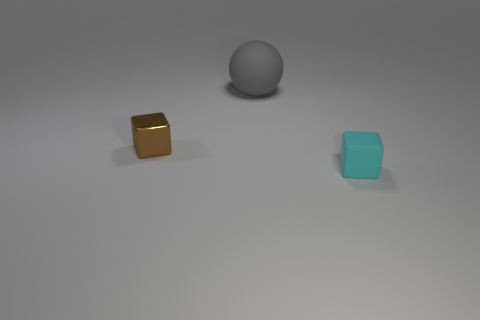Is there anything else that is the same shape as the big thing?
Provide a short and direct response. No. What number of cyan matte blocks have the same size as the brown thing?
Your response must be concise. 1. Does the brown shiny cube have the same size as the cube to the right of the tiny brown thing?
Your answer should be compact. Yes. What number of things are either small cyan matte cubes or big gray rubber balls?
Keep it short and to the point. 2. How many metallic blocks are the same color as the big rubber ball?
Provide a short and direct response. 0. What shape is the other matte object that is the same size as the brown thing?
Provide a short and direct response. Cube. Is there a small brown object of the same shape as the cyan object?
Make the answer very short. Yes. How many cyan cubes are made of the same material as the brown thing?
Provide a succinct answer. 0. Is the material of the block on the right side of the sphere the same as the brown cube?
Make the answer very short. No. Is the number of spheres behind the brown block greater than the number of big matte things in front of the cyan rubber object?
Your answer should be compact. Yes. 